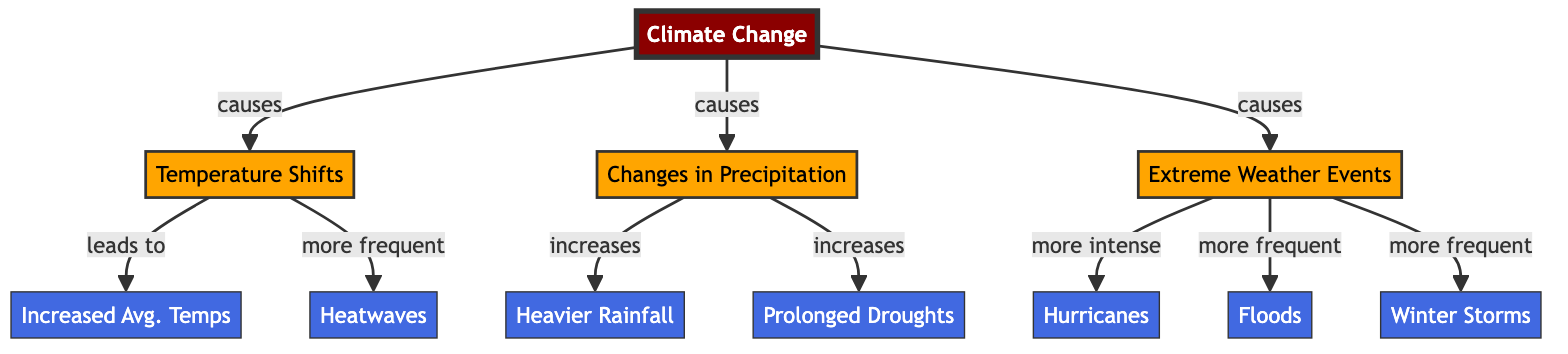What are the primary effects of climate change indicated in the diagram? The diagram identifies three main effects of climate change: temperature shifts, changes in precipitation, and extreme weather events. Each is visually represented by a separate node connected to the main topic.
Answer: Temperature shifts, changes in precipitation, extreme weather events How many effects are linked to temperature shifts? According to the diagram, temperature shifts lead to two effects: increased average temperatures and heatwaves. Each effect is directly connected to the temperature shifts node.
Answer: 2 What types of extreme weather events does the diagram mention? The diagram highlights three extreme weather events: hurricanes, floods, and winter storms. These are connected to the "Extreme Weather Events" node, showing that climate change causes these occurrences.
Answer: Hurricanes, floods, winter storms What kind of precipitation change is associated with climate change? The diagram states that climate change leads to "Heavier Rainfall" as a change in precipitation. This is indicated by a direct link from the "Changes in Precipitation" node.
Answer: Heavier rainfall What causes heatwaves according to the diagram? The diagram shows that heatwaves are caused by temperature shifts, which are a direct consequence of climate change. This is illustrated with an arrow from "Temperature Shifts" to "Heatwaves."
Answer: Temperature shifts How does climate change affect droughts? Climate change causes an increase in prolonged droughts, as indicated by the connection from "Changes in Precipitation" to "Prolonged Droughts" in the diagram. This illustrates that one of the consequences of climate change is more severe drought conditions.
Answer: Increases prolonged droughts 